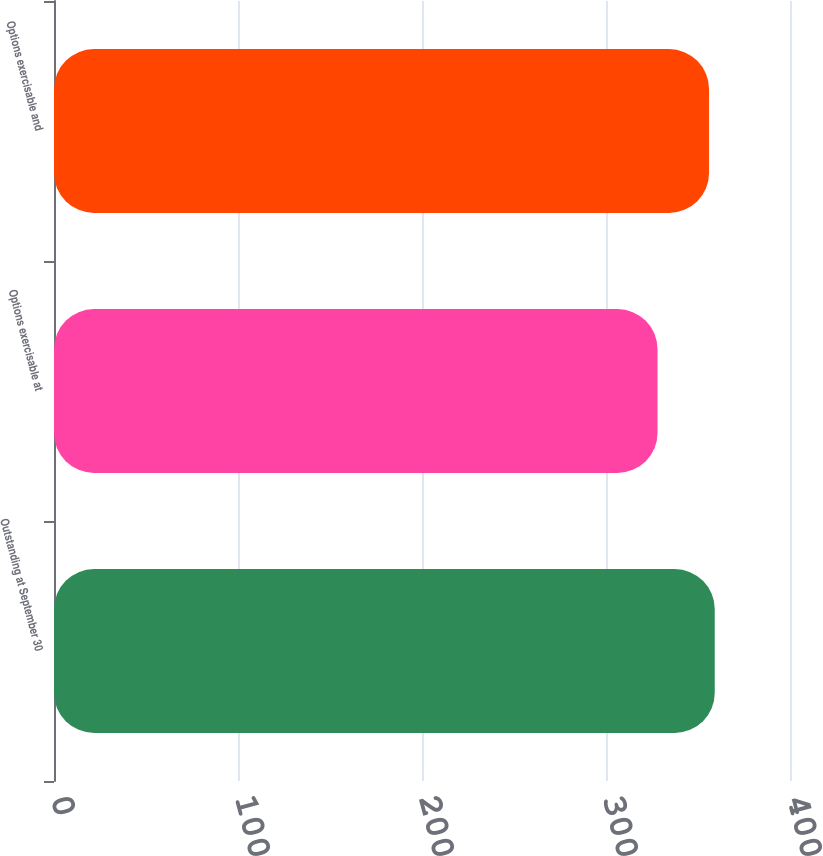<chart> <loc_0><loc_0><loc_500><loc_500><bar_chart><fcel>Outstanding at September 30<fcel>Options exercisable at<fcel>Options exercisable and<nl><fcel>359.1<fcel>328<fcel>356<nl></chart> 